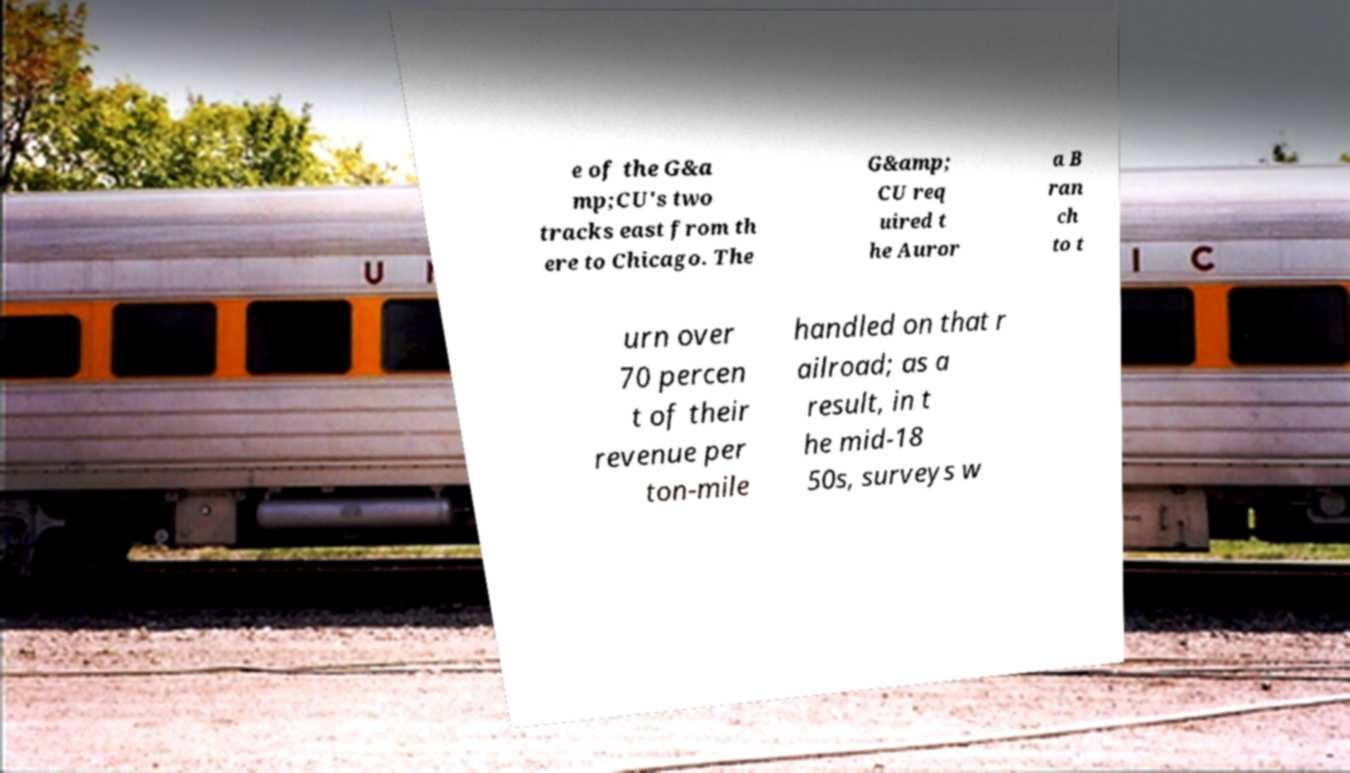For documentation purposes, I need the text within this image transcribed. Could you provide that? e of the G&a mp;CU's two tracks east from th ere to Chicago. The G&amp; CU req uired t he Auror a B ran ch to t urn over 70 percen t of their revenue per ton-mile handled on that r ailroad; as a result, in t he mid-18 50s, surveys w 